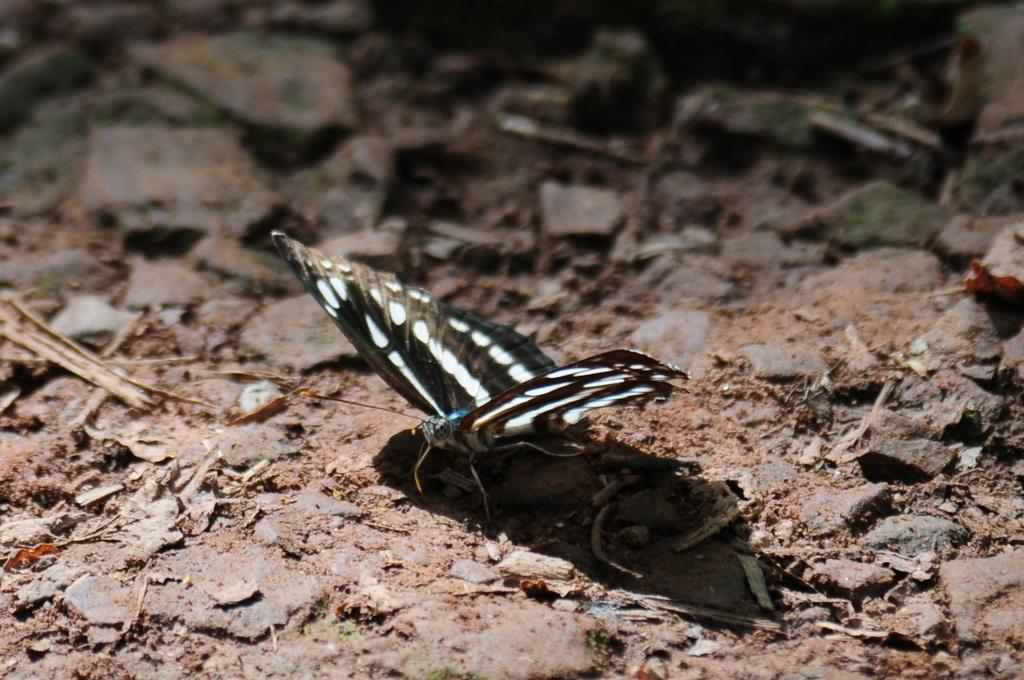What is the main subject of the image? There is a butterfly in the image. Where is the butterfly located? The butterfly is on the ground. Can you describe the time of day when the image might have been taken? The image may have been taken in the evening. What type of smile can be seen on the butterfly's face in the image? Butterflies do not have faces or the ability to smile, so this cannot be observed in the image. 